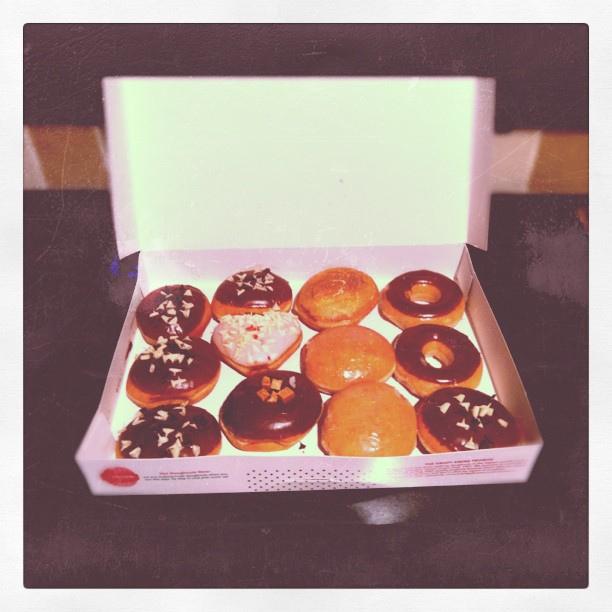Have any donuts been eaten?
Answer briefly. No. How many donuts are chocolate?
Write a very short answer. 8. Where are the donuts from?
Short answer required. Krispy kreme. How many donuts is on the plate?
Short answer required. 12. 